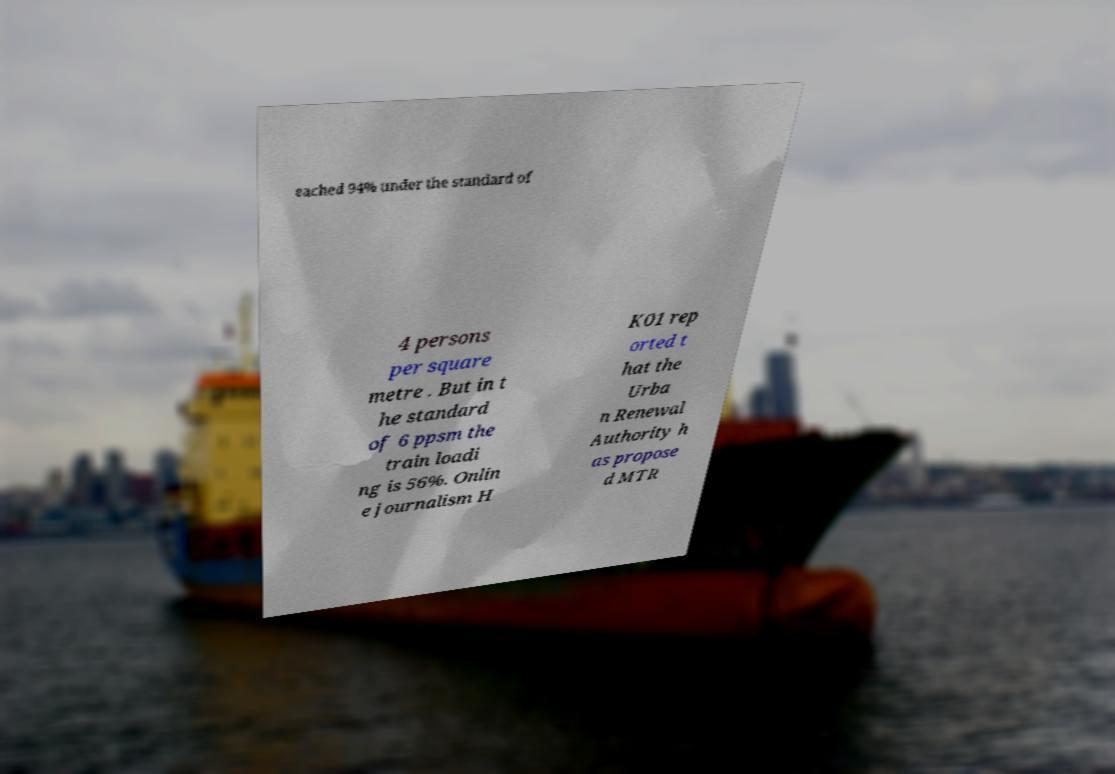Can you read and provide the text displayed in the image?This photo seems to have some interesting text. Can you extract and type it out for me? eached 94% under the standard of 4 persons per square metre . But in t he standard of 6 ppsm the train loadi ng is 56%. Onlin e journalism H K01 rep orted t hat the Urba n Renewal Authority h as propose d MTR 